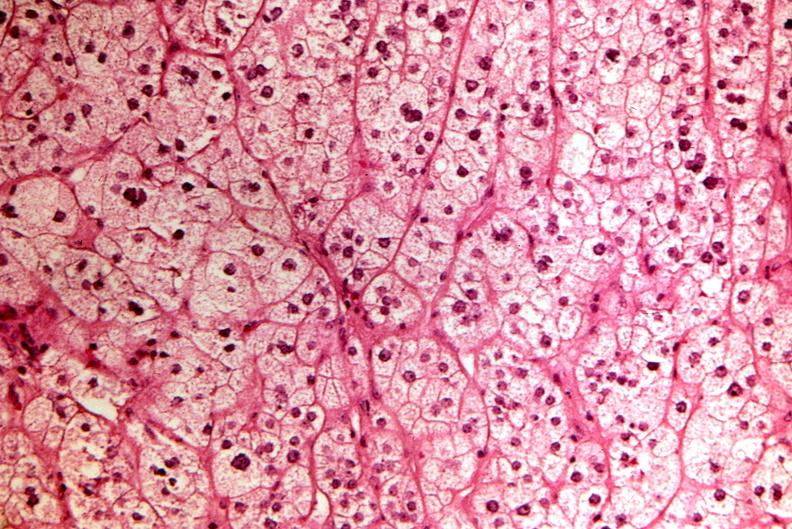does leiomyosarcoma show pituitary, chromaphobe adenoma?
Answer the question using a single word or phrase. No 